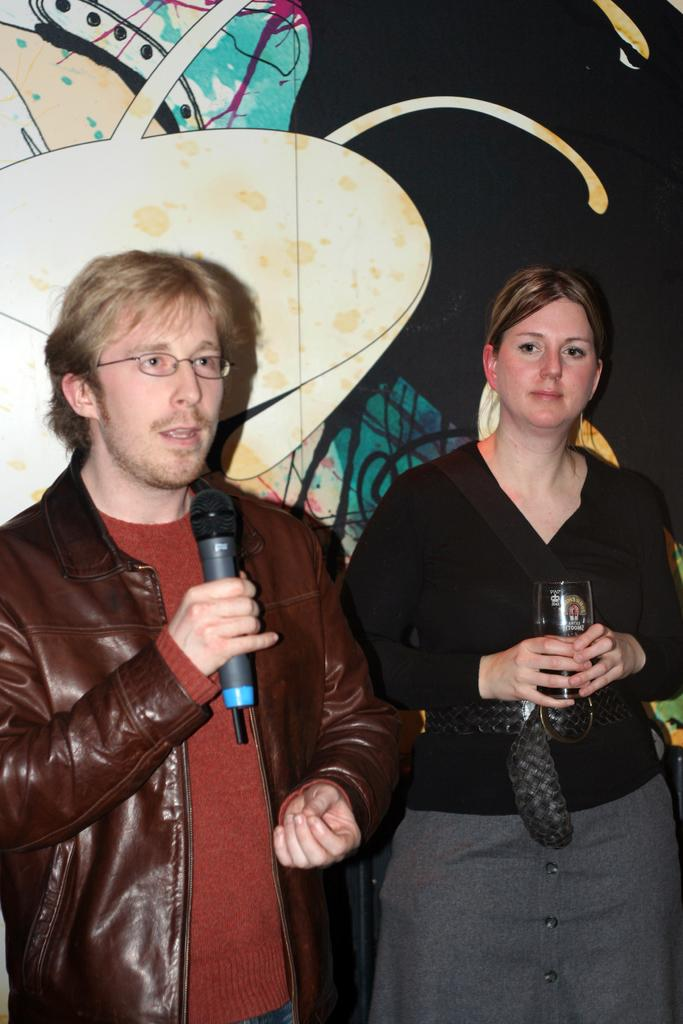What is the man in the image holding? The man is holding a mic in the image. Can you describe the man's appearance? The man is wearing glasses (specs) in the image. Who else is present in the image? There is a lady in the image. How is the lady positioned in relation to the man? The lady is standing near the man in the image. What is the lady holding in her hand? The lady is holding something in her hand, but the specific object is not mentioned in the facts. What can be seen in the background of the image? There are decorations visible in the background of the image. What type of government is being discussed by the man and lady in the image? There is no indication in the image that the man and lady are discussing any type of government. What kind of expertise does the man have in the image? The facts provided do not mention any specific expertise of the man. 